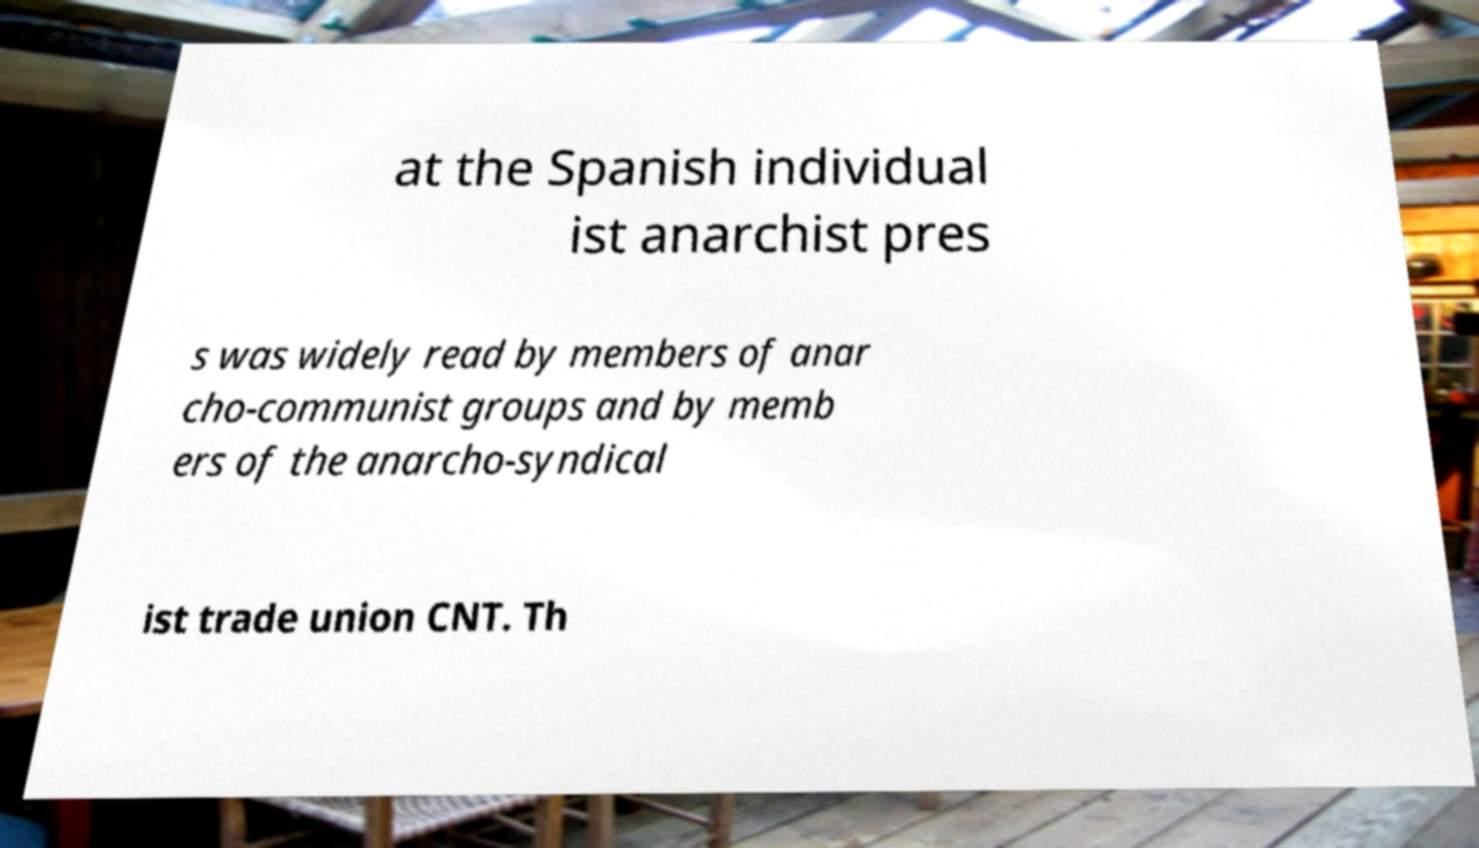I need the written content from this picture converted into text. Can you do that? at the Spanish individual ist anarchist pres s was widely read by members of anar cho-communist groups and by memb ers of the anarcho-syndical ist trade union CNT. Th 